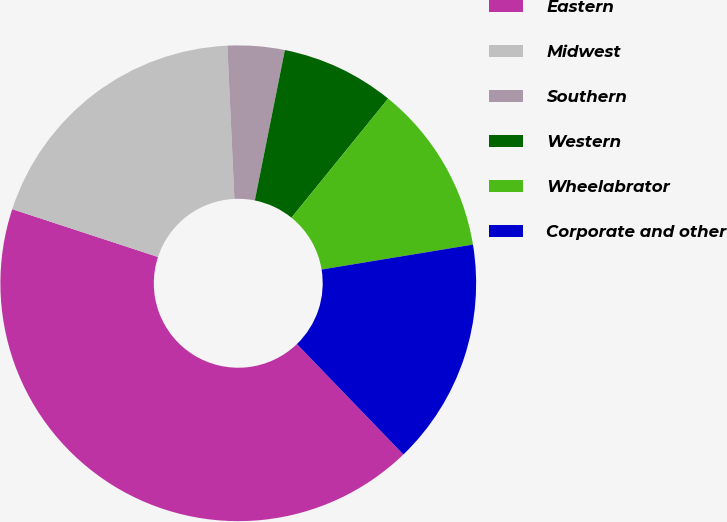Convert chart to OTSL. <chart><loc_0><loc_0><loc_500><loc_500><pie_chart><fcel>Eastern<fcel>Midwest<fcel>Southern<fcel>Western<fcel>Wheelabrator<fcel>Corporate and other<nl><fcel>42.26%<fcel>19.23%<fcel>3.87%<fcel>7.71%<fcel>11.55%<fcel>15.39%<nl></chart> 